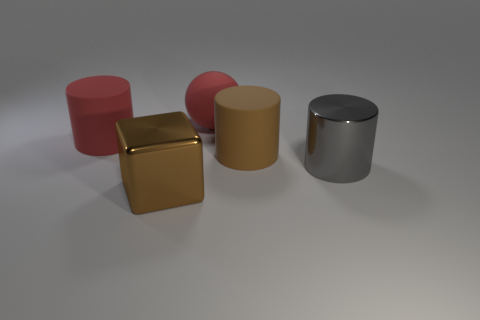What number of objects are either big objects in front of the large gray thing or large rubber objects?
Offer a very short reply. 4. What is the material of the ball to the left of the big brown thing that is behind the brown block?
Provide a short and direct response. Rubber. Is there another small thing of the same shape as the brown rubber object?
Your response must be concise. No. Does the metal cylinder have the same size as the red rubber object that is to the right of the brown block?
Your answer should be very brief. Yes. What number of objects are rubber cylinders right of the red cylinder or big rubber cylinders to the right of the matte sphere?
Your answer should be compact. 1. Are there more brown metal blocks that are in front of the big brown metallic cube than large brown metallic things?
Provide a succinct answer. No. How many blue metallic balls have the same size as the brown cylinder?
Make the answer very short. 0. There is a matte cylinder that is left of the rubber sphere; is it the same size as the brown object that is in front of the big metal cylinder?
Make the answer very short. Yes. There is a red rubber object that is on the right side of the large cube; how big is it?
Provide a short and direct response. Large. What is the size of the shiny thing that is right of the large brown thing that is in front of the large metal cylinder?
Provide a succinct answer. Large. 